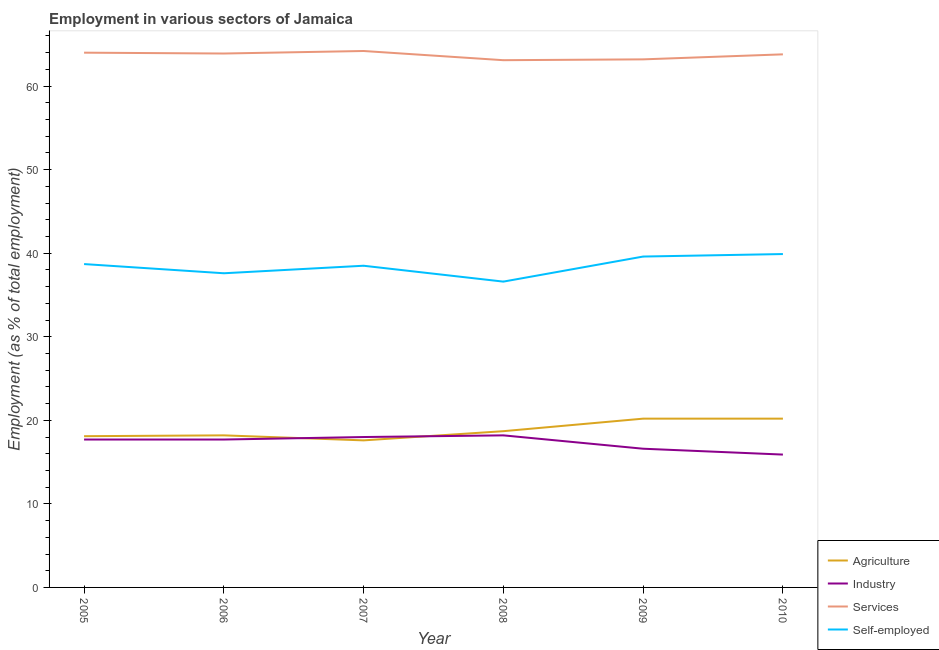Does the line corresponding to percentage of self employed workers intersect with the line corresponding to percentage of workers in industry?
Your answer should be very brief. No. Is the number of lines equal to the number of legend labels?
Your response must be concise. Yes. What is the percentage of workers in services in 2005?
Give a very brief answer. 64. Across all years, what is the maximum percentage of self employed workers?
Give a very brief answer. 39.9. Across all years, what is the minimum percentage of self employed workers?
Make the answer very short. 36.6. In which year was the percentage of workers in services maximum?
Your answer should be compact. 2007. What is the total percentage of workers in industry in the graph?
Make the answer very short. 104.1. What is the difference between the percentage of self employed workers in 2005 and that in 2008?
Keep it short and to the point. 2.1. What is the difference between the percentage of workers in industry in 2009 and the percentage of self employed workers in 2010?
Provide a short and direct response. -23.3. What is the average percentage of self employed workers per year?
Ensure brevity in your answer.  38.48. In the year 2005, what is the difference between the percentage of workers in services and percentage of workers in agriculture?
Provide a short and direct response. 45.9. In how many years, is the percentage of workers in industry greater than 52 %?
Provide a short and direct response. 0. What is the ratio of the percentage of workers in services in 2008 to that in 2009?
Your response must be concise. 1. Is the percentage of self employed workers in 2006 less than that in 2008?
Your answer should be very brief. No. Is the difference between the percentage of workers in services in 2005 and 2006 greater than the difference between the percentage of workers in industry in 2005 and 2006?
Your answer should be very brief. Yes. What is the difference between the highest and the second highest percentage of self employed workers?
Your answer should be very brief. 0.3. What is the difference between the highest and the lowest percentage of workers in services?
Ensure brevity in your answer.  1.1. Is the sum of the percentage of self employed workers in 2006 and 2008 greater than the maximum percentage of workers in agriculture across all years?
Your answer should be very brief. Yes. Is it the case that in every year, the sum of the percentage of workers in agriculture and percentage of workers in services is greater than the sum of percentage of self employed workers and percentage of workers in industry?
Provide a short and direct response. Yes. Is it the case that in every year, the sum of the percentage of workers in agriculture and percentage of workers in industry is greater than the percentage of workers in services?
Provide a short and direct response. No. Does the percentage of workers in services monotonically increase over the years?
Provide a short and direct response. No. Is the percentage of workers in agriculture strictly greater than the percentage of workers in services over the years?
Keep it short and to the point. No. Is the percentage of workers in services strictly less than the percentage of self employed workers over the years?
Keep it short and to the point. No. How many years are there in the graph?
Ensure brevity in your answer.  6. Are the values on the major ticks of Y-axis written in scientific E-notation?
Keep it short and to the point. No. Does the graph contain any zero values?
Provide a succinct answer. No. How many legend labels are there?
Your answer should be compact. 4. How are the legend labels stacked?
Ensure brevity in your answer.  Vertical. What is the title of the graph?
Make the answer very short. Employment in various sectors of Jamaica. Does "Quality of logistic services" appear as one of the legend labels in the graph?
Provide a short and direct response. No. What is the label or title of the X-axis?
Ensure brevity in your answer.  Year. What is the label or title of the Y-axis?
Offer a terse response. Employment (as % of total employment). What is the Employment (as % of total employment) in Agriculture in 2005?
Keep it short and to the point. 18.1. What is the Employment (as % of total employment) of Industry in 2005?
Make the answer very short. 17.7. What is the Employment (as % of total employment) of Services in 2005?
Your response must be concise. 64. What is the Employment (as % of total employment) of Self-employed in 2005?
Provide a short and direct response. 38.7. What is the Employment (as % of total employment) of Agriculture in 2006?
Your answer should be compact. 18.2. What is the Employment (as % of total employment) in Industry in 2006?
Provide a short and direct response. 17.7. What is the Employment (as % of total employment) in Services in 2006?
Provide a short and direct response. 63.9. What is the Employment (as % of total employment) of Self-employed in 2006?
Give a very brief answer. 37.6. What is the Employment (as % of total employment) in Agriculture in 2007?
Offer a very short reply. 17.6. What is the Employment (as % of total employment) of Services in 2007?
Your answer should be compact. 64.2. What is the Employment (as % of total employment) of Self-employed in 2007?
Ensure brevity in your answer.  38.5. What is the Employment (as % of total employment) in Agriculture in 2008?
Provide a short and direct response. 18.7. What is the Employment (as % of total employment) in Industry in 2008?
Give a very brief answer. 18.2. What is the Employment (as % of total employment) of Services in 2008?
Make the answer very short. 63.1. What is the Employment (as % of total employment) in Self-employed in 2008?
Give a very brief answer. 36.6. What is the Employment (as % of total employment) in Agriculture in 2009?
Provide a short and direct response. 20.2. What is the Employment (as % of total employment) in Industry in 2009?
Give a very brief answer. 16.6. What is the Employment (as % of total employment) in Services in 2009?
Offer a very short reply. 63.2. What is the Employment (as % of total employment) of Self-employed in 2009?
Provide a succinct answer. 39.6. What is the Employment (as % of total employment) in Agriculture in 2010?
Your answer should be compact. 20.2. What is the Employment (as % of total employment) of Industry in 2010?
Ensure brevity in your answer.  15.9. What is the Employment (as % of total employment) of Services in 2010?
Your response must be concise. 63.8. What is the Employment (as % of total employment) in Self-employed in 2010?
Give a very brief answer. 39.9. Across all years, what is the maximum Employment (as % of total employment) in Agriculture?
Offer a terse response. 20.2. Across all years, what is the maximum Employment (as % of total employment) in Industry?
Keep it short and to the point. 18.2. Across all years, what is the maximum Employment (as % of total employment) of Services?
Make the answer very short. 64.2. Across all years, what is the maximum Employment (as % of total employment) of Self-employed?
Offer a terse response. 39.9. Across all years, what is the minimum Employment (as % of total employment) in Agriculture?
Offer a terse response. 17.6. Across all years, what is the minimum Employment (as % of total employment) of Industry?
Your answer should be very brief. 15.9. Across all years, what is the minimum Employment (as % of total employment) of Services?
Provide a short and direct response. 63.1. Across all years, what is the minimum Employment (as % of total employment) of Self-employed?
Offer a very short reply. 36.6. What is the total Employment (as % of total employment) in Agriculture in the graph?
Your answer should be compact. 113. What is the total Employment (as % of total employment) in Industry in the graph?
Offer a terse response. 104.1. What is the total Employment (as % of total employment) in Services in the graph?
Give a very brief answer. 382.2. What is the total Employment (as % of total employment) of Self-employed in the graph?
Give a very brief answer. 230.9. What is the difference between the Employment (as % of total employment) of Agriculture in 2005 and that in 2006?
Your answer should be very brief. -0.1. What is the difference between the Employment (as % of total employment) of Industry in 2005 and that in 2006?
Your answer should be very brief. 0. What is the difference between the Employment (as % of total employment) of Services in 2005 and that in 2006?
Your response must be concise. 0.1. What is the difference between the Employment (as % of total employment) of Self-employed in 2005 and that in 2006?
Your response must be concise. 1.1. What is the difference between the Employment (as % of total employment) of Agriculture in 2005 and that in 2007?
Provide a short and direct response. 0.5. What is the difference between the Employment (as % of total employment) in Services in 2005 and that in 2007?
Offer a very short reply. -0.2. What is the difference between the Employment (as % of total employment) of Industry in 2005 and that in 2008?
Make the answer very short. -0.5. What is the difference between the Employment (as % of total employment) of Services in 2005 and that in 2008?
Provide a short and direct response. 0.9. What is the difference between the Employment (as % of total employment) in Self-employed in 2005 and that in 2008?
Keep it short and to the point. 2.1. What is the difference between the Employment (as % of total employment) of Agriculture in 2005 and that in 2009?
Offer a very short reply. -2.1. What is the difference between the Employment (as % of total employment) of Services in 2005 and that in 2009?
Your response must be concise. 0.8. What is the difference between the Employment (as % of total employment) in Self-employed in 2005 and that in 2010?
Give a very brief answer. -1.2. What is the difference between the Employment (as % of total employment) in Industry in 2006 and that in 2008?
Keep it short and to the point. -0.5. What is the difference between the Employment (as % of total employment) in Self-employed in 2006 and that in 2008?
Provide a short and direct response. 1. What is the difference between the Employment (as % of total employment) of Agriculture in 2006 and that in 2009?
Your answer should be compact. -2. What is the difference between the Employment (as % of total employment) of Agriculture in 2006 and that in 2010?
Your answer should be very brief. -2. What is the difference between the Employment (as % of total employment) of Industry in 2006 and that in 2010?
Your answer should be compact. 1.8. What is the difference between the Employment (as % of total employment) of Self-employed in 2006 and that in 2010?
Your answer should be compact. -2.3. What is the difference between the Employment (as % of total employment) of Industry in 2007 and that in 2008?
Keep it short and to the point. -0.2. What is the difference between the Employment (as % of total employment) in Services in 2007 and that in 2008?
Your answer should be compact. 1.1. What is the difference between the Employment (as % of total employment) in Self-employed in 2007 and that in 2008?
Provide a succinct answer. 1.9. What is the difference between the Employment (as % of total employment) in Services in 2007 and that in 2009?
Your answer should be compact. 1. What is the difference between the Employment (as % of total employment) of Services in 2007 and that in 2010?
Give a very brief answer. 0.4. What is the difference between the Employment (as % of total employment) of Self-employed in 2007 and that in 2010?
Provide a succinct answer. -1.4. What is the difference between the Employment (as % of total employment) of Agriculture in 2008 and that in 2009?
Make the answer very short. -1.5. What is the difference between the Employment (as % of total employment) in Services in 2008 and that in 2009?
Your answer should be very brief. -0.1. What is the difference between the Employment (as % of total employment) of Self-employed in 2008 and that in 2009?
Provide a short and direct response. -3. What is the difference between the Employment (as % of total employment) of Agriculture in 2008 and that in 2010?
Your answer should be compact. -1.5. What is the difference between the Employment (as % of total employment) in Industry in 2008 and that in 2010?
Ensure brevity in your answer.  2.3. What is the difference between the Employment (as % of total employment) in Self-employed in 2009 and that in 2010?
Make the answer very short. -0.3. What is the difference between the Employment (as % of total employment) of Agriculture in 2005 and the Employment (as % of total employment) of Industry in 2006?
Offer a terse response. 0.4. What is the difference between the Employment (as % of total employment) of Agriculture in 2005 and the Employment (as % of total employment) of Services in 2006?
Your answer should be compact. -45.8. What is the difference between the Employment (as % of total employment) in Agriculture in 2005 and the Employment (as % of total employment) in Self-employed in 2006?
Give a very brief answer. -19.5. What is the difference between the Employment (as % of total employment) of Industry in 2005 and the Employment (as % of total employment) of Services in 2006?
Your response must be concise. -46.2. What is the difference between the Employment (as % of total employment) of Industry in 2005 and the Employment (as % of total employment) of Self-employed in 2006?
Keep it short and to the point. -19.9. What is the difference between the Employment (as % of total employment) of Services in 2005 and the Employment (as % of total employment) of Self-employed in 2006?
Offer a terse response. 26.4. What is the difference between the Employment (as % of total employment) of Agriculture in 2005 and the Employment (as % of total employment) of Services in 2007?
Your answer should be compact. -46.1. What is the difference between the Employment (as % of total employment) in Agriculture in 2005 and the Employment (as % of total employment) in Self-employed in 2007?
Make the answer very short. -20.4. What is the difference between the Employment (as % of total employment) in Industry in 2005 and the Employment (as % of total employment) in Services in 2007?
Offer a terse response. -46.5. What is the difference between the Employment (as % of total employment) of Industry in 2005 and the Employment (as % of total employment) of Self-employed in 2007?
Your answer should be very brief. -20.8. What is the difference between the Employment (as % of total employment) in Agriculture in 2005 and the Employment (as % of total employment) in Services in 2008?
Keep it short and to the point. -45. What is the difference between the Employment (as % of total employment) in Agriculture in 2005 and the Employment (as % of total employment) in Self-employed in 2008?
Your answer should be compact. -18.5. What is the difference between the Employment (as % of total employment) in Industry in 2005 and the Employment (as % of total employment) in Services in 2008?
Your response must be concise. -45.4. What is the difference between the Employment (as % of total employment) in Industry in 2005 and the Employment (as % of total employment) in Self-employed in 2008?
Offer a terse response. -18.9. What is the difference between the Employment (as % of total employment) of Services in 2005 and the Employment (as % of total employment) of Self-employed in 2008?
Offer a terse response. 27.4. What is the difference between the Employment (as % of total employment) of Agriculture in 2005 and the Employment (as % of total employment) of Industry in 2009?
Keep it short and to the point. 1.5. What is the difference between the Employment (as % of total employment) in Agriculture in 2005 and the Employment (as % of total employment) in Services in 2009?
Keep it short and to the point. -45.1. What is the difference between the Employment (as % of total employment) in Agriculture in 2005 and the Employment (as % of total employment) in Self-employed in 2009?
Make the answer very short. -21.5. What is the difference between the Employment (as % of total employment) in Industry in 2005 and the Employment (as % of total employment) in Services in 2009?
Your answer should be compact. -45.5. What is the difference between the Employment (as % of total employment) in Industry in 2005 and the Employment (as % of total employment) in Self-employed in 2009?
Give a very brief answer. -21.9. What is the difference between the Employment (as % of total employment) of Services in 2005 and the Employment (as % of total employment) of Self-employed in 2009?
Ensure brevity in your answer.  24.4. What is the difference between the Employment (as % of total employment) in Agriculture in 2005 and the Employment (as % of total employment) in Services in 2010?
Your answer should be compact. -45.7. What is the difference between the Employment (as % of total employment) of Agriculture in 2005 and the Employment (as % of total employment) of Self-employed in 2010?
Your answer should be compact. -21.8. What is the difference between the Employment (as % of total employment) of Industry in 2005 and the Employment (as % of total employment) of Services in 2010?
Ensure brevity in your answer.  -46.1. What is the difference between the Employment (as % of total employment) in Industry in 2005 and the Employment (as % of total employment) in Self-employed in 2010?
Your answer should be compact. -22.2. What is the difference between the Employment (as % of total employment) in Services in 2005 and the Employment (as % of total employment) in Self-employed in 2010?
Offer a terse response. 24.1. What is the difference between the Employment (as % of total employment) of Agriculture in 2006 and the Employment (as % of total employment) of Industry in 2007?
Give a very brief answer. 0.2. What is the difference between the Employment (as % of total employment) of Agriculture in 2006 and the Employment (as % of total employment) of Services in 2007?
Offer a very short reply. -46. What is the difference between the Employment (as % of total employment) in Agriculture in 2006 and the Employment (as % of total employment) in Self-employed in 2007?
Offer a terse response. -20.3. What is the difference between the Employment (as % of total employment) in Industry in 2006 and the Employment (as % of total employment) in Services in 2007?
Provide a succinct answer. -46.5. What is the difference between the Employment (as % of total employment) in Industry in 2006 and the Employment (as % of total employment) in Self-employed in 2007?
Your answer should be very brief. -20.8. What is the difference between the Employment (as % of total employment) of Services in 2006 and the Employment (as % of total employment) of Self-employed in 2007?
Give a very brief answer. 25.4. What is the difference between the Employment (as % of total employment) in Agriculture in 2006 and the Employment (as % of total employment) in Industry in 2008?
Your answer should be very brief. 0. What is the difference between the Employment (as % of total employment) in Agriculture in 2006 and the Employment (as % of total employment) in Services in 2008?
Your answer should be very brief. -44.9. What is the difference between the Employment (as % of total employment) of Agriculture in 2006 and the Employment (as % of total employment) of Self-employed in 2008?
Provide a succinct answer. -18.4. What is the difference between the Employment (as % of total employment) of Industry in 2006 and the Employment (as % of total employment) of Services in 2008?
Keep it short and to the point. -45.4. What is the difference between the Employment (as % of total employment) of Industry in 2006 and the Employment (as % of total employment) of Self-employed in 2008?
Offer a terse response. -18.9. What is the difference between the Employment (as % of total employment) of Services in 2006 and the Employment (as % of total employment) of Self-employed in 2008?
Offer a very short reply. 27.3. What is the difference between the Employment (as % of total employment) in Agriculture in 2006 and the Employment (as % of total employment) in Industry in 2009?
Keep it short and to the point. 1.6. What is the difference between the Employment (as % of total employment) of Agriculture in 2006 and the Employment (as % of total employment) of Services in 2009?
Provide a short and direct response. -45. What is the difference between the Employment (as % of total employment) in Agriculture in 2006 and the Employment (as % of total employment) in Self-employed in 2009?
Provide a succinct answer. -21.4. What is the difference between the Employment (as % of total employment) in Industry in 2006 and the Employment (as % of total employment) in Services in 2009?
Ensure brevity in your answer.  -45.5. What is the difference between the Employment (as % of total employment) of Industry in 2006 and the Employment (as % of total employment) of Self-employed in 2009?
Keep it short and to the point. -21.9. What is the difference between the Employment (as % of total employment) of Services in 2006 and the Employment (as % of total employment) of Self-employed in 2009?
Make the answer very short. 24.3. What is the difference between the Employment (as % of total employment) in Agriculture in 2006 and the Employment (as % of total employment) in Services in 2010?
Ensure brevity in your answer.  -45.6. What is the difference between the Employment (as % of total employment) in Agriculture in 2006 and the Employment (as % of total employment) in Self-employed in 2010?
Make the answer very short. -21.7. What is the difference between the Employment (as % of total employment) in Industry in 2006 and the Employment (as % of total employment) in Services in 2010?
Keep it short and to the point. -46.1. What is the difference between the Employment (as % of total employment) in Industry in 2006 and the Employment (as % of total employment) in Self-employed in 2010?
Your response must be concise. -22.2. What is the difference between the Employment (as % of total employment) in Services in 2006 and the Employment (as % of total employment) in Self-employed in 2010?
Keep it short and to the point. 24. What is the difference between the Employment (as % of total employment) in Agriculture in 2007 and the Employment (as % of total employment) in Industry in 2008?
Your answer should be compact. -0.6. What is the difference between the Employment (as % of total employment) in Agriculture in 2007 and the Employment (as % of total employment) in Services in 2008?
Your answer should be compact. -45.5. What is the difference between the Employment (as % of total employment) in Industry in 2007 and the Employment (as % of total employment) in Services in 2008?
Offer a terse response. -45.1. What is the difference between the Employment (as % of total employment) of Industry in 2007 and the Employment (as % of total employment) of Self-employed in 2008?
Your answer should be very brief. -18.6. What is the difference between the Employment (as % of total employment) in Services in 2007 and the Employment (as % of total employment) in Self-employed in 2008?
Provide a succinct answer. 27.6. What is the difference between the Employment (as % of total employment) of Agriculture in 2007 and the Employment (as % of total employment) of Services in 2009?
Give a very brief answer. -45.6. What is the difference between the Employment (as % of total employment) in Agriculture in 2007 and the Employment (as % of total employment) in Self-employed in 2009?
Provide a succinct answer. -22. What is the difference between the Employment (as % of total employment) of Industry in 2007 and the Employment (as % of total employment) of Services in 2009?
Offer a terse response. -45.2. What is the difference between the Employment (as % of total employment) of Industry in 2007 and the Employment (as % of total employment) of Self-employed in 2009?
Your answer should be very brief. -21.6. What is the difference between the Employment (as % of total employment) of Services in 2007 and the Employment (as % of total employment) of Self-employed in 2009?
Your answer should be compact. 24.6. What is the difference between the Employment (as % of total employment) of Agriculture in 2007 and the Employment (as % of total employment) of Industry in 2010?
Offer a very short reply. 1.7. What is the difference between the Employment (as % of total employment) of Agriculture in 2007 and the Employment (as % of total employment) of Services in 2010?
Provide a short and direct response. -46.2. What is the difference between the Employment (as % of total employment) in Agriculture in 2007 and the Employment (as % of total employment) in Self-employed in 2010?
Make the answer very short. -22.3. What is the difference between the Employment (as % of total employment) in Industry in 2007 and the Employment (as % of total employment) in Services in 2010?
Make the answer very short. -45.8. What is the difference between the Employment (as % of total employment) in Industry in 2007 and the Employment (as % of total employment) in Self-employed in 2010?
Provide a short and direct response. -21.9. What is the difference between the Employment (as % of total employment) of Services in 2007 and the Employment (as % of total employment) of Self-employed in 2010?
Offer a very short reply. 24.3. What is the difference between the Employment (as % of total employment) of Agriculture in 2008 and the Employment (as % of total employment) of Services in 2009?
Provide a succinct answer. -44.5. What is the difference between the Employment (as % of total employment) of Agriculture in 2008 and the Employment (as % of total employment) of Self-employed in 2009?
Make the answer very short. -20.9. What is the difference between the Employment (as % of total employment) in Industry in 2008 and the Employment (as % of total employment) in Services in 2009?
Your response must be concise. -45. What is the difference between the Employment (as % of total employment) of Industry in 2008 and the Employment (as % of total employment) of Self-employed in 2009?
Give a very brief answer. -21.4. What is the difference between the Employment (as % of total employment) in Agriculture in 2008 and the Employment (as % of total employment) in Industry in 2010?
Keep it short and to the point. 2.8. What is the difference between the Employment (as % of total employment) in Agriculture in 2008 and the Employment (as % of total employment) in Services in 2010?
Your answer should be compact. -45.1. What is the difference between the Employment (as % of total employment) of Agriculture in 2008 and the Employment (as % of total employment) of Self-employed in 2010?
Your answer should be compact. -21.2. What is the difference between the Employment (as % of total employment) of Industry in 2008 and the Employment (as % of total employment) of Services in 2010?
Your answer should be very brief. -45.6. What is the difference between the Employment (as % of total employment) in Industry in 2008 and the Employment (as % of total employment) in Self-employed in 2010?
Make the answer very short. -21.7. What is the difference between the Employment (as % of total employment) of Services in 2008 and the Employment (as % of total employment) of Self-employed in 2010?
Your answer should be compact. 23.2. What is the difference between the Employment (as % of total employment) of Agriculture in 2009 and the Employment (as % of total employment) of Services in 2010?
Ensure brevity in your answer.  -43.6. What is the difference between the Employment (as % of total employment) of Agriculture in 2009 and the Employment (as % of total employment) of Self-employed in 2010?
Offer a very short reply. -19.7. What is the difference between the Employment (as % of total employment) in Industry in 2009 and the Employment (as % of total employment) in Services in 2010?
Your answer should be very brief. -47.2. What is the difference between the Employment (as % of total employment) in Industry in 2009 and the Employment (as % of total employment) in Self-employed in 2010?
Provide a succinct answer. -23.3. What is the difference between the Employment (as % of total employment) of Services in 2009 and the Employment (as % of total employment) of Self-employed in 2010?
Provide a succinct answer. 23.3. What is the average Employment (as % of total employment) of Agriculture per year?
Provide a short and direct response. 18.83. What is the average Employment (as % of total employment) in Industry per year?
Give a very brief answer. 17.35. What is the average Employment (as % of total employment) of Services per year?
Your answer should be very brief. 63.7. What is the average Employment (as % of total employment) of Self-employed per year?
Make the answer very short. 38.48. In the year 2005, what is the difference between the Employment (as % of total employment) of Agriculture and Employment (as % of total employment) of Industry?
Give a very brief answer. 0.4. In the year 2005, what is the difference between the Employment (as % of total employment) of Agriculture and Employment (as % of total employment) of Services?
Provide a short and direct response. -45.9. In the year 2005, what is the difference between the Employment (as % of total employment) of Agriculture and Employment (as % of total employment) of Self-employed?
Make the answer very short. -20.6. In the year 2005, what is the difference between the Employment (as % of total employment) in Industry and Employment (as % of total employment) in Services?
Keep it short and to the point. -46.3. In the year 2005, what is the difference between the Employment (as % of total employment) of Industry and Employment (as % of total employment) of Self-employed?
Offer a terse response. -21. In the year 2005, what is the difference between the Employment (as % of total employment) of Services and Employment (as % of total employment) of Self-employed?
Make the answer very short. 25.3. In the year 2006, what is the difference between the Employment (as % of total employment) in Agriculture and Employment (as % of total employment) in Industry?
Offer a very short reply. 0.5. In the year 2006, what is the difference between the Employment (as % of total employment) of Agriculture and Employment (as % of total employment) of Services?
Your response must be concise. -45.7. In the year 2006, what is the difference between the Employment (as % of total employment) in Agriculture and Employment (as % of total employment) in Self-employed?
Offer a terse response. -19.4. In the year 2006, what is the difference between the Employment (as % of total employment) of Industry and Employment (as % of total employment) of Services?
Your answer should be very brief. -46.2. In the year 2006, what is the difference between the Employment (as % of total employment) of Industry and Employment (as % of total employment) of Self-employed?
Offer a very short reply. -19.9. In the year 2006, what is the difference between the Employment (as % of total employment) of Services and Employment (as % of total employment) of Self-employed?
Your answer should be very brief. 26.3. In the year 2007, what is the difference between the Employment (as % of total employment) in Agriculture and Employment (as % of total employment) in Services?
Offer a very short reply. -46.6. In the year 2007, what is the difference between the Employment (as % of total employment) of Agriculture and Employment (as % of total employment) of Self-employed?
Your response must be concise. -20.9. In the year 2007, what is the difference between the Employment (as % of total employment) of Industry and Employment (as % of total employment) of Services?
Your response must be concise. -46.2. In the year 2007, what is the difference between the Employment (as % of total employment) in Industry and Employment (as % of total employment) in Self-employed?
Ensure brevity in your answer.  -20.5. In the year 2007, what is the difference between the Employment (as % of total employment) in Services and Employment (as % of total employment) in Self-employed?
Keep it short and to the point. 25.7. In the year 2008, what is the difference between the Employment (as % of total employment) in Agriculture and Employment (as % of total employment) in Services?
Provide a short and direct response. -44.4. In the year 2008, what is the difference between the Employment (as % of total employment) of Agriculture and Employment (as % of total employment) of Self-employed?
Ensure brevity in your answer.  -17.9. In the year 2008, what is the difference between the Employment (as % of total employment) of Industry and Employment (as % of total employment) of Services?
Your answer should be very brief. -44.9. In the year 2008, what is the difference between the Employment (as % of total employment) of Industry and Employment (as % of total employment) of Self-employed?
Make the answer very short. -18.4. In the year 2008, what is the difference between the Employment (as % of total employment) in Services and Employment (as % of total employment) in Self-employed?
Your response must be concise. 26.5. In the year 2009, what is the difference between the Employment (as % of total employment) of Agriculture and Employment (as % of total employment) of Services?
Provide a succinct answer. -43. In the year 2009, what is the difference between the Employment (as % of total employment) of Agriculture and Employment (as % of total employment) of Self-employed?
Your answer should be very brief. -19.4. In the year 2009, what is the difference between the Employment (as % of total employment) of Industry and Employment (as % of total employment) of Services?
Offer a terse response. -46.6. In the year 2009, what is the difference between the Employment (as % of total employment) in Industry and Employment (as % of total employment) in Self-employed?
Ensure brevity in your answer.  -23. In the year 2009, what is the difference between the Employment (as % of total employment) of Services and Employment (as % of total employment) of Self-employed?
Give a very brief answer. 23.6. In the year 2010, what is the difference between the Employment (as % of total employment) of Agriculture and Employment (as % of total employment) of Services?
Make the answer very short. -43.6. In the year 2010, what is the difference between the Employment (as % of total employment) in Agriculture and Employment (as % of total employment) in Self-employed?
Offer a terse response. -19.7. In the year 2010, what is the difference between the Employment (as % of total employment) in Industry and Employment (as % of total employment) in Services?
Your answer should be very brief. -47.9. In the year 2010, what is the difference between the Employment (as % of total employment) in Services and Employment (as % of total employment) in Self-employed?
Provide a succinct answer. 23.9. What is the ratio of the Employment (as % of total employment) of Agriculture in 2005 to that in 2006?
Give a very brief answer. 0.99. What is the ratio of the Employment (as % of total employment) in Industry in 2005 to that in 2006?
Ensure brevity in your answer.  1. What is the ratio of the Employment (as % of total employment) in Services in 2005 to that in 2006?
Provide a succinct answer. 1. What is the ratio of the Employment (as % of total employment) of Self-employed in 2005 to that in 2006?
Provide a short and direct response. 1.03. What is the ratio of the Employment (as % of total employment) of Agriculture in 2005 to that in 2007?
Provide a short and direct response. 1.03. What is the ratio of the Employment (as % of total employment) in Industry in 2005 to that in 2007?
Provide a succinct answer. 0.98. What is the ratio of the Employment (as % of total employment) of Services in 2005 to that in 2007?
Provide a short and direct response. 1. What is the ratio of the Employment (as % of total employment) of Agriculture in 2005 to that in 2008?
Offer a terse response. 0.97. What is the ratio of the Employment (as % of total employment) in Industry in 2005 to that in 2008?
Your answer should be very brief. 0.97. What is the ratio of the Employment (as % of total employment) of Services in 2005 to that in 2008?
Offer a very short reply. 1.01. What is the ratio of the Employment (as % of total employment) in Self-employed in 2005 to that in 2008?
Provide a short and direct response. 1.06. What is the ratio of the Employment (as % of total employment) of Agriculture in 2005 to that in 2009?
Give a very brief answer. 0.9. What is the ratio of the Employment (as % of total employment) in Industry in 2005 to that in 2009?
Your answer should be compact. 1.07. What is the ratio of the Employment (as % of total employment) of Services in 2005 to that in 2009?
Provide a succinct answer. 1.01. What is the ratio of the Employment (as % of total employment) of Self-employed in 2005 to that in 2009?
Ensure brevity in your answer.  0.98. What is the ratio of the Employment (as % of total employment) in Agriculture in 2005 to that in 2010?
Keep it short and to the point. 0.9. What is the ratio of the Employment (as % of total employment) of Industry in 2005 to that in 2010?
Give a very brief answer. 1.11. What is the ratio of the Employment (as % of total employment) of Self-employed in 2005 to that in 2010?
Provide a succinct answer. 0.97. What is the ratio of the Employment (as % of total employment) in Agriculture in 2006 to that in 2007?
Your answer should be very brief. 1.03. What is the ratio of the Employment (as % of total employment) in Industry in 2006 to that in 2007?
Your answer should be compact. 0.98. What is the ratio of the Employment (as % of total employment) in Services in 2006 to that in 2007?
Offer a terse response. 1. What is the ratio of the Employment (as % of total employment) of Self-employed in 2006 to that in 2007?
Your response must be concise. 0.98. What is the ratio of the Employment (as % of total employment) of Agriculture in 2006 to that in 2008?
Provide a short and direct response. 0.97. What is the ratio of the Employment (as % of total employment) in Industry in 2006 to that in 2008?
Provide a succinct answer. 0.97. What is the ratio of the Employment (as % of total employment) of Services in 2006 to that in 2008?
Offer a terse response. 1.01. What is the ratio of the Employment (as % of total employment) of Self-employed in 2006 to that in 2008?
Offer a terse response. 1.03. What is the ratio of the Employment (as % of total employment) of Agriculture in 2006 to that in 2009?
Ensure brevity in your answer.  0.9. What is the ratio of the Employment (as % of total employment) of Industry in 2006 to that in 2009?
Your answer should be compact. 1.07. What is the ratio of the Employment (as % of total employment) of Services in 2006 to that in 2009?
Make the answer very short. 1.01. What is the ratio of the Employment (as % of total employment) in Self-employed in 2006 to that in 2009?
Provide a succinct answer. 0.95. What is the ratio of the Employment (as % of total employment) in Agriculture in 2006 to that in 2010?
Ensure brevity in your answer.  0.9. What is the ratio of the Employment (as % of total employment) of Industry in 2006 to that in 2010?
Ensure brevity in your answer.  1.11. What is the ratio of the Employment (as % of total employment) of Self-employed in 2006 to that in 2010?
Make the answer very short. 0.94. What is the ratio of the Employment (as % of total employment) of Agriculture in 2007 to that in 2008?
Provide a succinct answer. 0.94. What is the ratio of the Employment (as % of total employment) of Industry in 2007 to that in 2008?
Provide a short and direct response. 0.99. What is the ratio of the Employment (as % of total employment) in Services in 2007 to that in 2008?
Your answer should be compact. 1.02. What is the ratio of the Employment (as % of total employment) in Self-employed in 2007 to that in 2008?
Keep it short and to the point. 1.05. What is the ratio of the Employment (as % of total employment) of Agriculture in 2007 to that in 2009?
Ensure brevity in your answer.  0.87. What is the ratio of the Employment (as % of total employment) in Industry in 2007 to that in 2009?
Give a very brief answer. 1.08. What is the ratio of the Employment (as % of total employment) of Services in 2007 to that in 2009?
Offer a terse response. 1.02. What is the ratio of the Employment (as % of total employment) in Self-employed in 2007 to that in 2009?
Ensure brevity in your answer.  0.97. What is the ratio of the Employment (as % of total employment) in Agriculture in 2007 to that in 2010?
Give a very brief answer. 0.87. What is the ratio of the Employment (as % of total employment) in Industry in 2007 to that in 2010?
Your response must be concise. 1.13. What is the ratio of the Employment (as % of total employment) in Self-employed in 2007 to that in 2010?
Make the answer very short. 0.96. What is the ratio of the Employment (as % of total employment) in Agriculture in 2008 to that in 2009?
Ensure brevity in your answer.  0.93. What is the ratio of the Employment (as % of total employment) of Industry in 2008 to that in 2009?
Your response must be concise. 1.1. What is the ratio of the Employment (as % of total employment) of Services in 2008 to that in 2009?
Ensure brevity in your answer.  1. What is the ratio of the Employment (as % of total employment) in Self-employed in 2008 to that in 2009?
Your answer should be very brief. 0.92. What is the ratio of the Employment (as % of total employment) of Agriculture in 2008 to that in 2010?
Offer a terse response. 0.93. What is the ratio of the Employment (as % of total employment) of Industry in 2008 to that in 2010?
Provide a short and direct response. 1.14. What is the ratio of the Employment (as % of total employment) of Services in 2008 to that in 2010?
Your response must be concise. 0.99. What is the ratio of the Employment (as % of total employment) in Self-employed in 2008 to that in 2010?
Provide a short and direct response. 0.92. What is the ratio of the Employment (as % of total employment) in Agriculture in 2009 to that in 2010?
Your answer should be very brief. 1. What is the ratio of the Employment (as % of total employment) in Industry in 2009 to that in 2010?
Your answer should be very brief. 1.04. What is the ratio of the Employment (as % of total employment) in Services in 2009 to that in 2010?
Keep it short and to the point. 0.99. What is the difference between the highest and the second highest Employment (as % of total employment) in Agriculture?
Offer a very short reply. 0. What is the difference between the highest and the second highest Employment (as % of total employment) in Services?
Give a very brief answer. 0.2. What is the difference between the highest and the lowest Employment (as % of total employment) of Self-employed?
Make the answer very short. 3.3. 